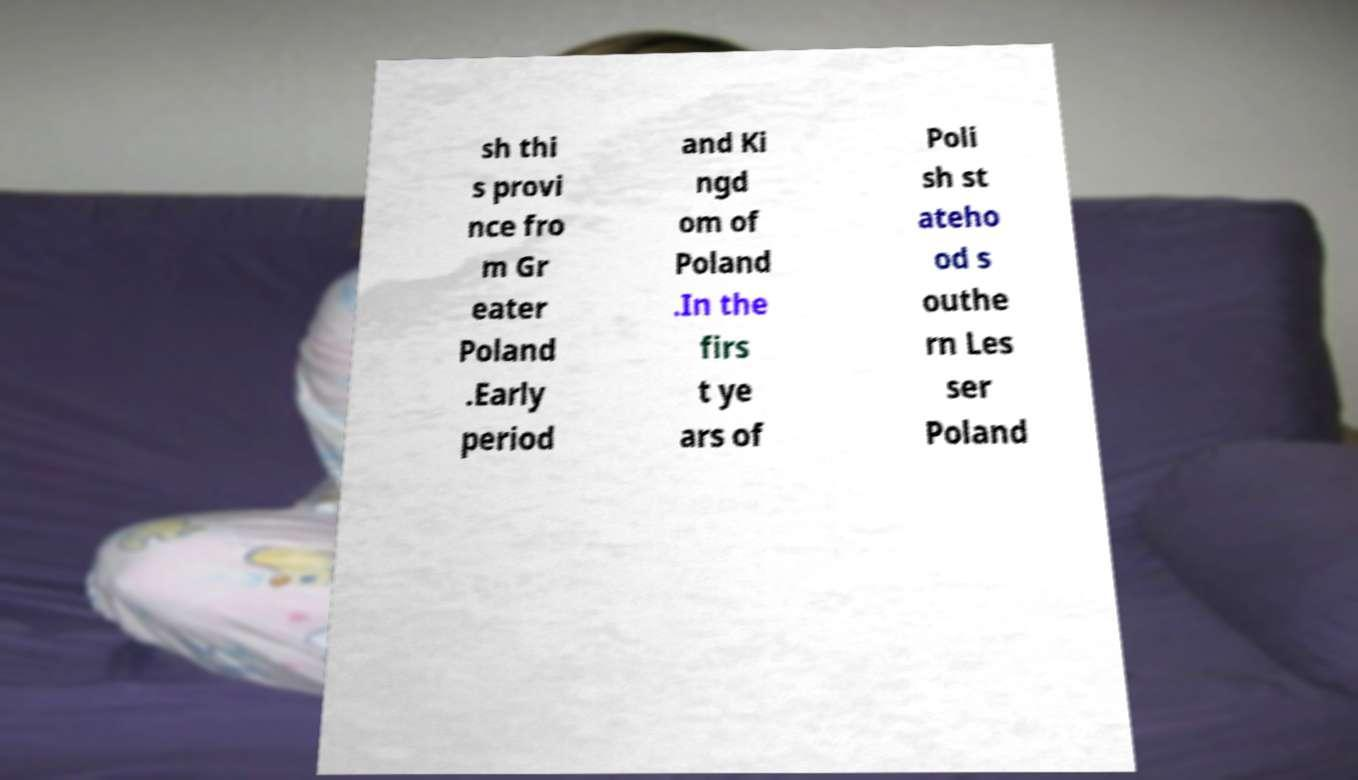What messages or text are displayed in this image? I need them in a readable, typed format. sh thi s provi nce fro m Gr eater Poland .Early period and Ki ngd om of Poland .In the firs t ye ars of Poli sh st ateho od s outhe rn Les ser Poland 